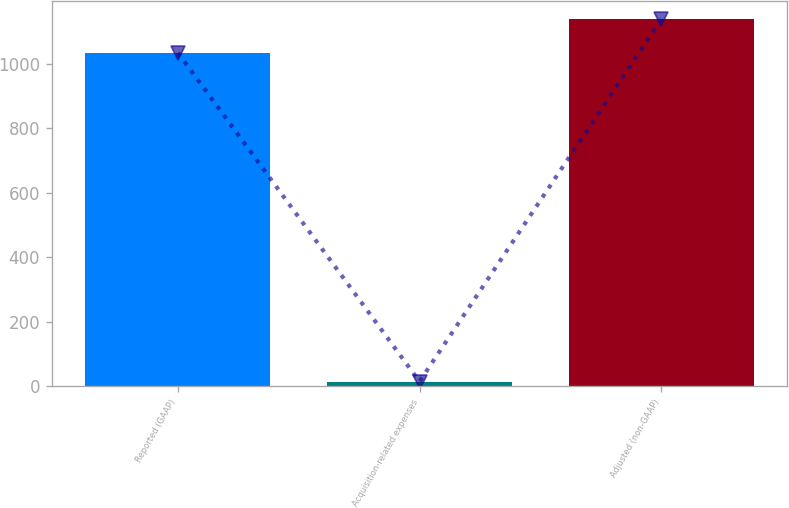<chart> <loc_0><loc_0><loc_500><loc_500><bar_chart><fcel>Reported (GAAP)<fcel>Acquisition-related expenses<fcel>Adjusted (non-GAAP)<nl><fcel>1034.6<fcel>14.1<fcel>1138.06<nl></chart> 